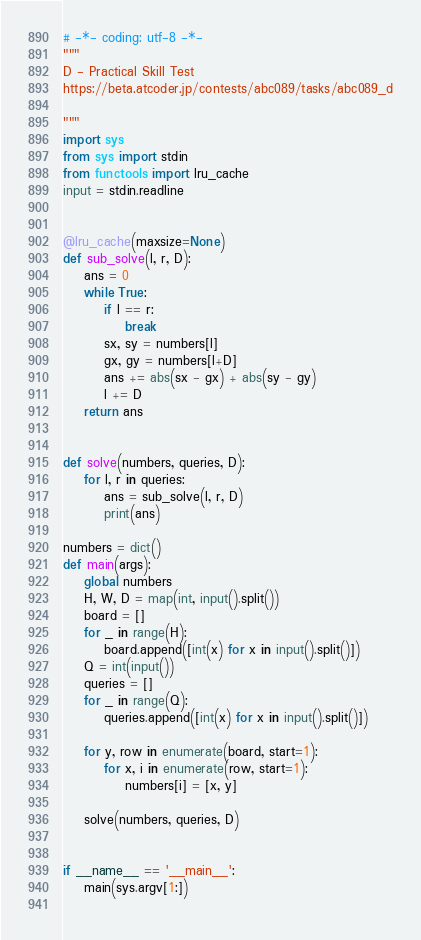<code> <loc_0><loc_0><loc_500><loc_500><_Python_># -*- coding: utf-8 -*-
"""
D - Practical Skill Test
https://beta.atcoder.jp/contests/abc089/tasks/abc089_d

"""
import sys
from sys import stdin
from functools import lru_cache
input = stdin.readline


@lru_cache(maxsize=None)
def sub_solve(l, r, D):
    ans = 0
    while True:
        if l == r:
            break
        sx, sy = numbers[l]
        gx, gy = numbers[l+D]
        ans += abs(sx - gx) + abs(sy - gy)
        l += D
    return ans


def solve(numbers, queries, D):
    for l, r in queries:
        ans = sub_solve(l, r, D)
        print(ans)

numbers = dict()
def main(args):
    global numbers
    H, W, D = map(int, input().split())
    board = []
    for _ in range(H):
        board.append([int(x) for x in input().split()])
    Q = int(input())
    queries = []
    for _ in range(Q):
        queries.append([int(x) for x in input().split()])

    for y, row in enumerate(board, start=1):
        for x, i in enumerate(row, start=1):
            numbers[i] = [x, y]

    solve(numbers, queries, D)


if __name__ == '__main__':
    main(sys.argv[1:])
    
</code> 